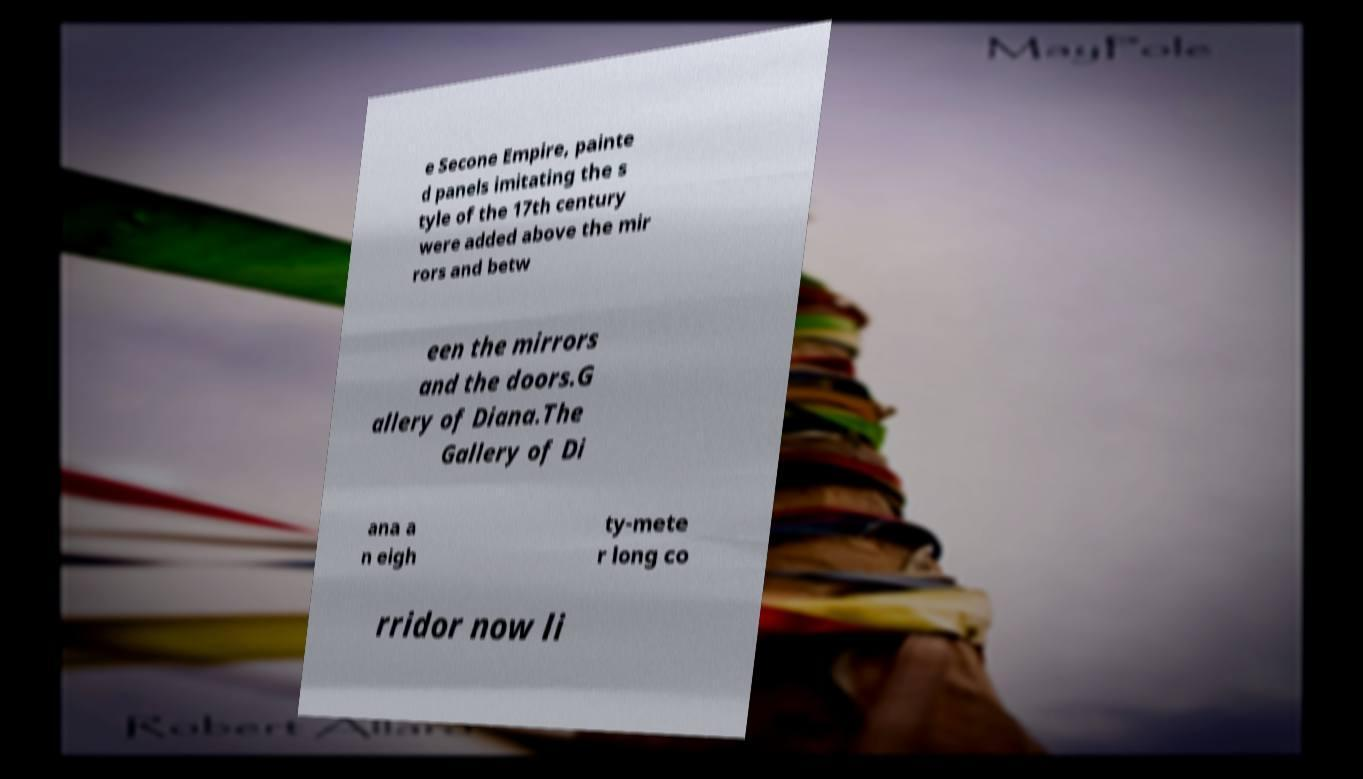Could you extract and type out the text from this image? e Secone Empire, painte d panels imitating the s tyle of the 17th century were added above the mir rors and betw een the mirrors and the doors.G allery of Diana.The Gallery of Di ana a n eigh ty-mete r long co rridor now li 